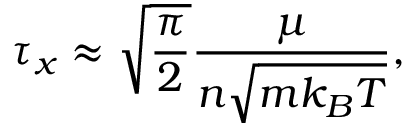Convert formula to latex. <formula><loc_0><loc_0><loc_500><loc_500>\tau _ { x } \approx \sqrt { \frac { \pi } { 2 } } \frac { \mu } { n \sqrt { m k _ { B } T } } ,</formula> 